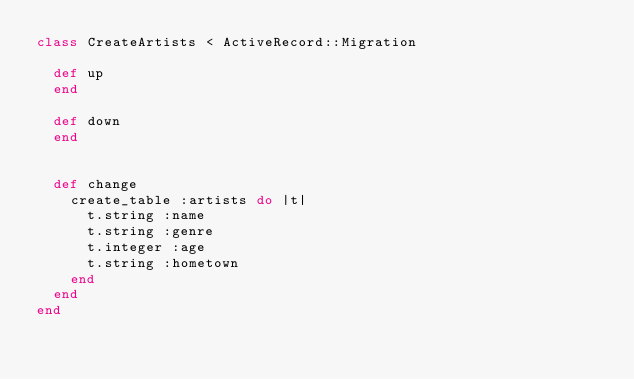Convert code to text. <code><loc_0><loc_0><loc_500><loc_500><_Ruby_>class CreateArtists < ActiveRecord::Migration

  def up
  end

  def down
  end

  
  def change
    create_table :artists do |t|
      t.string :name
      t.string :genre
      t.integer :age
      t.string :hometown
    end
  end
end
</code> 